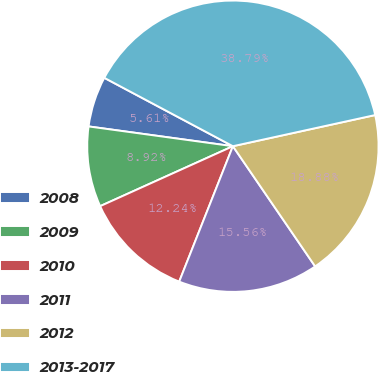Convert chart. <chart><loc_0><loc_0><loc_500><loc_500><pie_chart><fcel>2008<fcel>2009<fcel>2010<fcel>2011<fcel>2012<fcel>2013-2017<nl><fcel>5.61%<fcel>8.92%<fcel>12.24%<fcel>15.56%<fcel>18.88%<fcel>38.79%<nl></chart> 